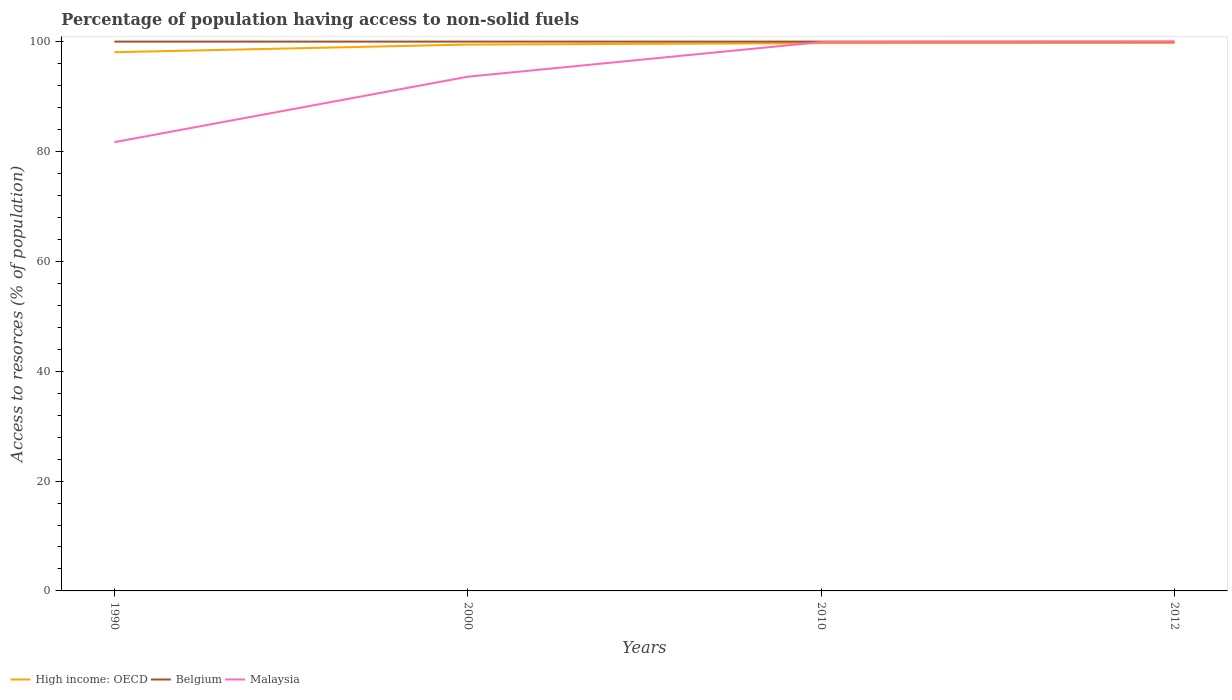Across all years, what is the maximum percentage of population having access to non-solid fuels in Malaysia?
Provide a succinct answer. 81.69. In which year was the percentage of population having access to non-solid fuels in High income: OECD maximum?
Ensure brevity in your answer.  1990. What is the total percentage of population having access to non-solid fuels in Malaysia in the graph?
Keep it short and to the point. -6.38. What is the difference between the highest and the second highest percentage of population having access to non-solid fuels in High income: OECD?
Keep it short and to the point. 1.69. What is the difference between the highest and the lowest percentage of population having access to non-solid fuels in Malaysia?
Provide a short and direct response. 2. Is the percentage of population having access to non-solid fuels in High income: OECD strictly greater than the percentage of population having access to non-solid fuels in Malaysia over the years?
Your answer should be very brief. No. Are the values on the major ticks of Y-axis written in scientific E-notation?
Your answer should be very brief. No. Does the graph contain any zero values?
Keep it short and to the point. No. Does the graph contain grids?
Ensure brevity in your answer.  No. How many legend labels are there?
Offer a terse response. 3. How are the legend labels stacked?
Your answer should be very brief. Horizontal. What is the title of the graph?
Your response must be concise. Percentage of population having access to non-solid fuels. What is the label or title of the Y-axis?
Offer a very short reply. Access to resorces (% of population). What is the Access to resorces (% of population) of High income: OECD in 1990?
Offer a terse response. 98.07. What is the Access to resorces (% of population) of Malaysia in 1990?
Offer a terse response. 81.69. What is the Access to resorces (% of population) of High income: OECD in 2000?
Ensure brevity in your answer.  99.46. What is the Access to resorces (% of population) in Malaysia in 2000?
Give a very brief answer. 93.61. What is the Access to resorces (% of population) in High income: OECD in 2010?
Your answer should be very brief. 99.72. What is the Access to resorces (% of population) of Malaysia in 2010?
Ensure brevity in your answer.  99.92. What is the Access to resorces (% of population) in High income: OECD in 2012?
Ensure brevity in your answer.  99.75. What is the Access to resorces (% of population) of Malaysia in 2012?
Provide a succinct answer. 99.99. Across all years, what is the maximum Access to resorces (% of population) in High income: OECD?
Keep it short and to the point. 99.75. Across all years, what is the maximum Access to resorces (% of population) of Belgium?
Offer a terse response. 100. Across all years, what is the maximum Access to resorces (% of population) of Malaysia?
Your answer should be compact. 99.99. Across all years, what is the minimum Access to resorces (% of population) of High income: OECD?
Your answer should be compact. 98.07. Across all years, what is the minimum Access to resorces (% of population) in Belgium?
Provide a succinct answer. 100. Across all years, what is the minimum Access to resorces (% of population) in Malaysia?
Offer a very short reply. 81.69. What is the total Access to resorces (% of population) in High income: OECD in the graph?
Keep it short and to the point. 397. What is the total Access to resorces (% of population) of Malaysia in the graph?
Your answer should be very brief. 375.21. What is the difference between the Access to resorces (% of population) in High income: OECD in 1990 and that in 2000?
Your answer should be very brief. -1.39. What is the difference between the Access to resorces (% of population) in Belgium in 1990 and that in 2000?
Give a very brief answer. 0. What is the difference between the Access to resorces (% of population) in Malaysia in 1990 and that in 2000?
Make the answer very short. -11.92. What is the difference between the Access to resorces (% of population) of High income: OECD in 1990 and that in 2010?
Keep it short and to the point. -1.65. What is the difference between the Access to resorces (% of population) of Malaysia in 1990 and that in 2010?
Your answer should be compact. -18.23. What is the difference between the Access to resorces (% of population) in High income: OECD in 1990 and that in 2012?
Your answer should be very brief. -1.69. What is the difference between the Access to resorces (% of population) of Malaysia in 1990 and that in 2012?
Keep it short and to the point. -18.3. What is the difference between the Access to resorces (% of population) of High income: OECD in 2000 and that in 2010?
Keep it short and to the point. -0.26. What is the difference between the Access to resorces (% of population) in Belgium in 2000 and that in 2010?
Keep it short and to the point. 0. What is the difference between the Access to resorces (% of population) of Malaysia in 2000 and that in 2010?
Make the answer very short. -6.31. What is the difference between the Access to resorces (% of population) in High income: OECD in 2000 and that in 2012?
Ensure brevity in your answer.  -0.29. What is the difference between the Access to resorces (% of population) in Belgium in 2000 and that in 2012?
Ensure brevity in your answer.  0. What is the difference between the Access to resorces (% of population) of Malaysia in 2000 and that in 2012?
Your answer should be very brief. -6.38. What is the difference between the Access to resorces (% of population) of High income: OECD in 2010 and that in 2012?
Ensure brevity in your answer.  -0.03. What is the difference between the Access to resorces (% of population) of Malaysia in 2010 and that in 2012?
Provide a short and direct response. -0.07. What is the difference between the Access to resorces (% of population) in High income: OECD in 1990 and the Access to resorces (% of population) in Belgium in 2000?
Your answer should be very brief. -1.93. What is the difference between the Access to resorces (% of population) of High income: OECD in 1990 and the Access to resorces (% of population) of Malaysia in 2000?
Offer a very short reply. 4.46. What is the difference between the Access to resorces (% of population) of Belgium in 1990 and the Access to resorces (% of population) of Malaysia in 2000?
Your response must be concise. 6.39. What is the difference between the Access to resorces (% of population) of High income: OECD in 1990 and the Access to resorces (% of population) of Belgium in 2010?
Offer a very short reply. -1.93. What is the difference between the Access to resorces (% of population) in High income: OECD in 1990 and the Access to resorces (% of population) in Malaysia in 2010?
Offer a terse response. -1.85. What is the difference between the Access to resorces (% of population) of Belgium in 1990 and the Access to resorces (% of population) of Malaysia in 2010?
Offer a very short reply. 0.08. What is the difference between the Access to resorces (% of population) of High income: OECD in 1990 and the Access to resorces (% of population) of Belgium in 2012?
Provide a succinct answer. -1.93. What is the difference between the Access to resorces (% of population) in High income: OECD in 1990 and the Access to resorces (% of population) in Malaysia in 2012?
Ensure brevity in your answer.  -1.92. What is the difference between the Access to resorces (% of population) of Belgium in 1990 and the Access to resorces (% of population) of Malaysia in 2012?
Offer a terse response. 0.01. What is the difference between the Access to resorces (% of population) in High income: OECD in 2000 and the Access to resorces (% of population) in Belgium in 2010?
Your answer should be compact. -0.54. What is the difference between the Access to resorces (% of population) in High income: OECD in 2000 and the Access to resorces (% of population) in Malaysia in 2010?
Provide a succinct answer. -0.46. What is the difference between the Access to resorces (% of population) in Belgium in 2000 and the Access to resorces (% of population) in Malaysia in 2010?
Your answer should be very brief. 0.08. What is the difference between the Access to resorces (% of population) of High income: OECD in 2000 and the Access to resorces (% of population) of Belgium in 2012?
Ensure brevity in your answer.  -0.54. What is the difference between the Access to resorces (% of population) in High income: OECD in 2000 and the Access to resorces (% of population) in Malaysia in 2012?
Give a very brief answer. -0.53. What is the difference between the Access to resorces (% of population) of Belgium in 2000 and the Access to resorces (% of population) of Malaysia in 2012?
Make the answer very short. 0.01. What is the difference between the Access to resorces (% of population) of High income: OECD in 2010 and the Access to resorces (% of population) of Belgium in 2012?
Keep it short and to the point. -0.28. What is the difference between the Access to resorces (% of population) in High income: OECD in 2010 and the Access to resorces (% of population) in Malaysia in 2012?
Give a very brief answer. -0.27. What is the difference between the Access to resorces (% of population) of Belgium in 2010 and the Access to resorces (% of population) of Malaysia in 2012?
Give a very brief answer. 0.01. What is the average Access to resorces (% of population) in High income: OECD per year?
Offer a terse response. 99.25. What is the average Access to resorces (% of population) in Belgium per year?
Provide a succinct answer. 100. What is the average Access to resorces (% of population) of Malaysia per year?
Provide a short and direct response. 93.8. In the year 1990, what is the difference between the Access to resorces (% of population) of High income: OECD and Access to resorces (% of population) of Belgium?
Ensure brevity in your answer.  -1.93. In the year 1990, what is the difference between the Access to resorces (% of population) of High income: OECD and Access to resorces (% of population) of Malaysia?
Provide a succinct answer. 16.38. In the year 1990, what is the difference between the Access to resorces (% of population) in Belgium and Access to resorces (% of population) in Malaysia?
Offer a very short reply. 18.31. In the year 2000, what is the difference between the Access to resorces (% of population) of High income: OECD and Access to resorces (% of population) of Belgium?
Offer a very short reply. -0.54. In the year 2000, what is the difference between the Access to resorces (% of population) of High income: OECD and Access to resorces (% of population) of Malaysia?
Provide a short and direct response. 5.85. In the year 2000, what is the difference between the Access to resorces (% of population) of Belgium and Access to resorces (% of population) of Malaysia?
Provide a short and direct response. 6.39. In the year 2010, what is the difference between the Access to resorces (% of population) of High income: OECD and Access to resorces (% of population) of Belgium?
Give a very brief answer. -0.28. In the year 2010, what is the difference between the Access to resorces (% of population) of High income: OECD and Access to resorces (% of population) of Malaysia?
Offer a very short reply. -0.2. In the year 2010, what is the difference between the Access to resorces (% of population) in Belgium and Access to resorces (% of population) in Malaysia?
Provide a short and direct response. 0.08. In the year 2012, what is the difference between the Access to resorces (% of population) in High income: OECD and Access to resorces (% of population) in Belgium?
Make the answer very short. -0.25. In the year 2012, what is the difference between the Access to resorces (% of population) in High income: OECD and Access to resorces (% of population) in Malaysia?
Your response must be concise. -0.24. In the year 2012, what is the difference between the Access to resorces (% of population) of Belgium and Access to resorces (% of population) of Malaysia?
Your answer should be very brief. 0.01. What is the ratio of the Access to resorces (% of population) in Malaysia in 1990 to that in 2000?
Provide a succinct answer. 0.87. What is the ratio of the Access to resorces (% of population) in High income: OECD in 1990 to that in 2010?
Your answer should be compact. 0.98. What is the ratio of the Access to resorces (% of population) in Belgium in 1990 to that in 2010?
Offer a very short reply. 1. What is the ratio of the Access to resorces (% of population) in Malaysia in 1990 to that in 2010?
Provide a succinct answer. 0.82. What is the ratio of the Access to resorces (% of population) of High income: OECD in 1990 to that in 2012?
Provide a short and direct response. 0.98. What is the ratio of the Access to resorces (% of population) in Malaysia in 1990 to that in 2012?
Offer a very short reply. 0.82. What is the ratio of the Access to resorces (% of population) in Belgium in 2000 to that in 2010?
Your answer should be very brief. 1. What is the ratio of the Access to resorces (% of population) in Malaysia in 2000 to that in 2010?
Provide a short and direct response. 0.94. What is the ratio of the Access to resorces (% of population) of High income: OECD in 2000 to that in 2012?
Your response must be concise. 1. What is the ratio of the Access to resorces (% of population) of Belgium in 2000 to that in 2012?
Provide a short and direct response. 1. What is the ratio of the Access to resorces (% of population) of Malaysia in 2000 to that in 2012?
Your answer should be compact. 0.94. What is the difference between the highest and the second highest Access to resorces (% of population) of High income: OECD?
Your answer should be compact. 0.03. What is the difference between the highest and the second highest Access to resorces (% of population) in Malaysia?
Your answer should be very brief. 0.07. What is the difference between the highest and the lowest Access to resorces (% of population) in High income: OECD?
Your answer should be compact. 1.69. What is the difference between the highest and the lowest Access to resorces (% of population) of Belgium?
Your answer should be compact. 0. What is the difference between the highest and the lowest Access to resorces (% of population) of Malaysia?
Offer a terse response. 18.3. 